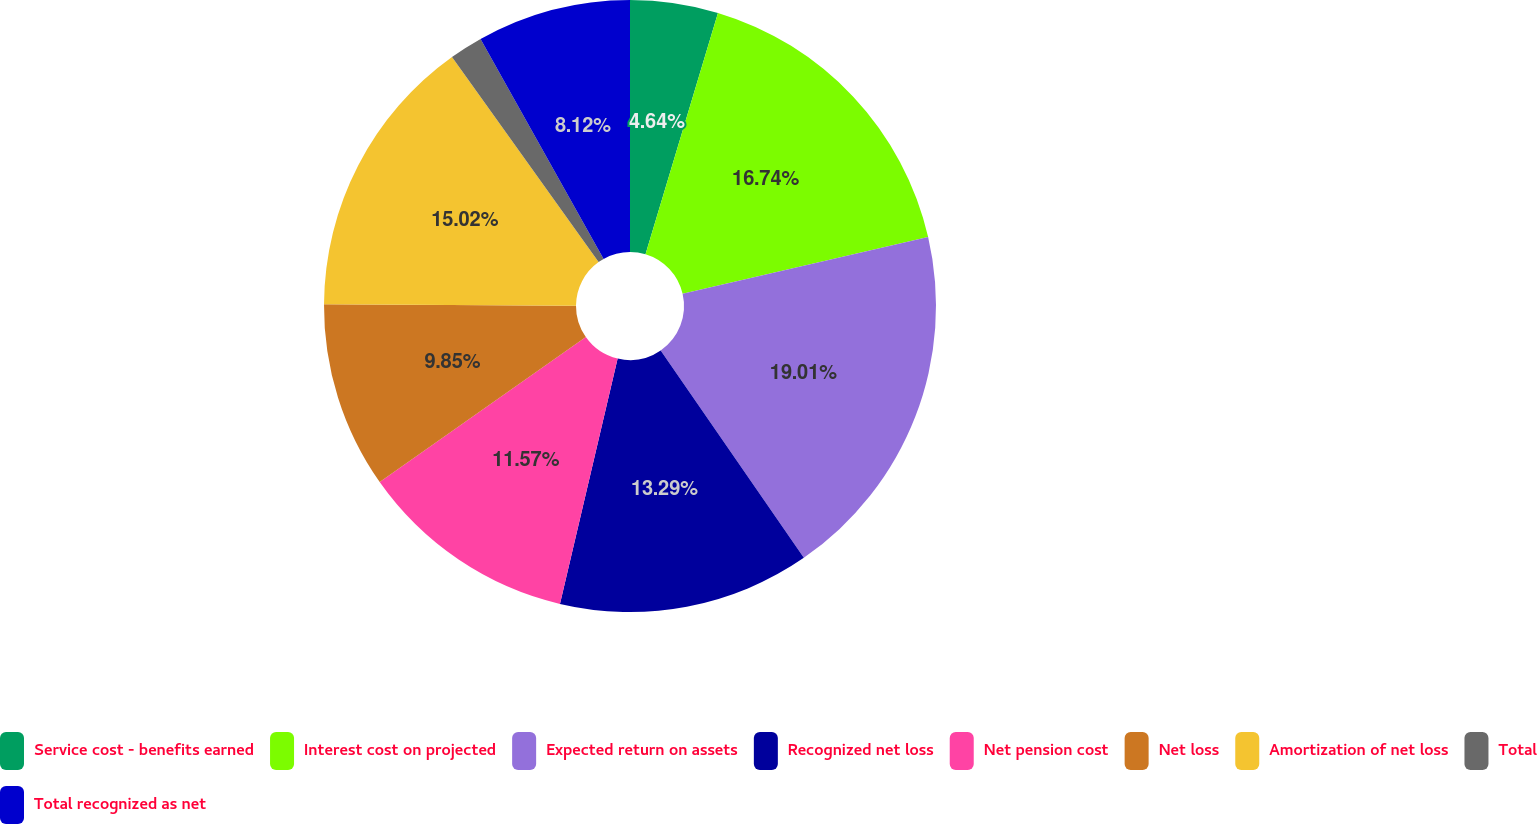Convert chart. <chart><loc_0><loc_0><loc_500><loc_500><pie_chart><fcel>Service cost - benefits earned<fcel>Interest cost on projected<fcel>Expected return on assets<fcel>Recognized net loss<fcel>Net pension cost<fcel>Net loss<fcel>Amortization of net loss<fcel>Total<fcel>Total recognized as net<nl><fcel>4.64%<fcel>16.74%<fcel>19.0%<fcel>13.29%<fcel>11.57%<fcel>9.85%<fcel>15.02%<fcel>1.76%<fcel>8.12%<nl></chart> 